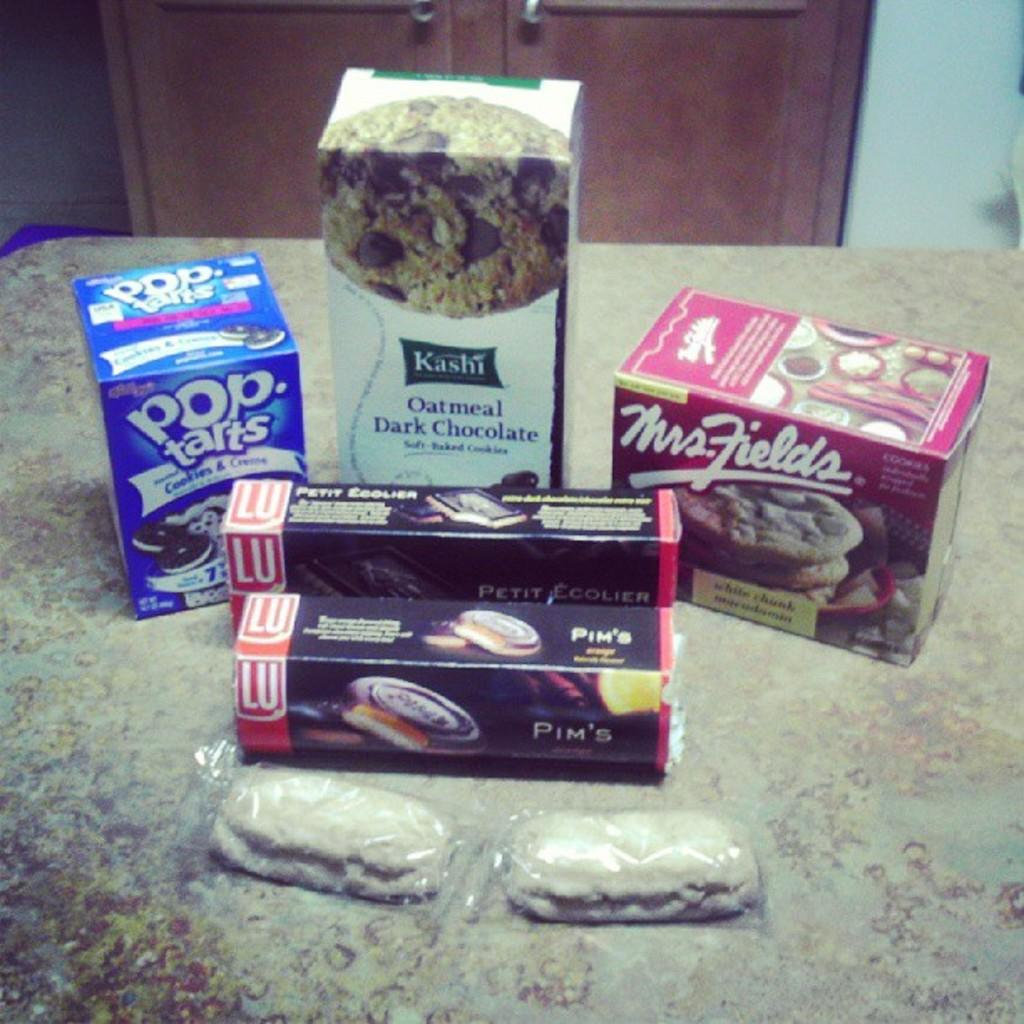What type of food items are visible in the image? There are boxes of snacks in the image. Where are the snack covers placed? The snack covers are placed on a wooden surface. What type of furniture is visible at the top of the image? It appears that there is a cupboard at the top of the image. What type of horn can be seen on the snack boxes in the image? There are no horns present on the snack boxes in the image. 